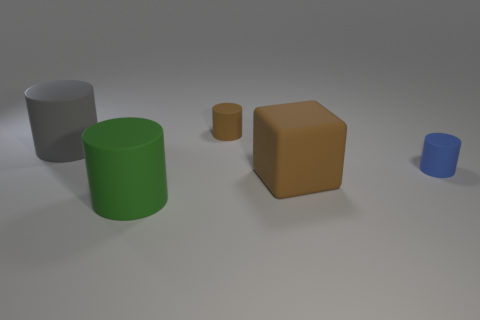What is the shape of the tiny matte thing that is on the right side of the tiny cylinder behind the tiny blue matte thing?
Your answer should be compact. Cylinder. Are there fewer large gray things to the right of the large green rubber cylinder than large brown rubber blocks?
Provide a succinct answer. Yes. There is a object that is the same color as the big matte cube; what shape is it?
Keep it short and to the point. Cylinder. What number of brown matte cubes are the same size as the gray cylinder?
Make the answer very short. 1. What shape is the brown thing behind the blue thing?
Your response must be concise. Cylinder. Is the number of small cylinders less than the number of red rubber things?
Offer a terse response. No. Is there any other thing of the same color as the big cube?
Provide a succinct answer. Yes. How big is the matte thing that is on the right side of the matte block?
Your response must be concise. Small. Is the number of blue rubber cylinders greater than the number of big objects?
Provide a succinct answer. No. What is the material of the green cylinder?
Your answer should be compact. Rubber. 